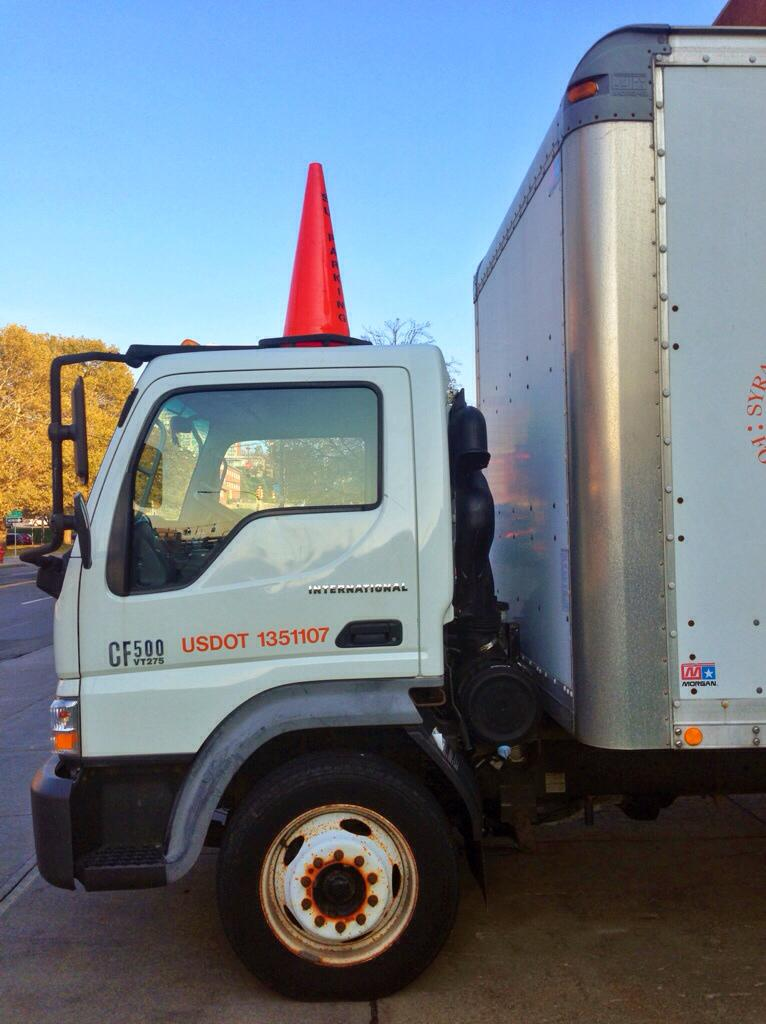What is the main feature of the image? There is a road in the image. What else can be seen on the road? There is a vehicle in the image. What can be seen in the distance behind the road? There are trees in the background of the image. What is visible above the road and trees? The sky is visible in the image. What type of tooth is being used to fix the road in the image? There is no tooth present in the image, and the road does not appear to be undergoing any repair work. 